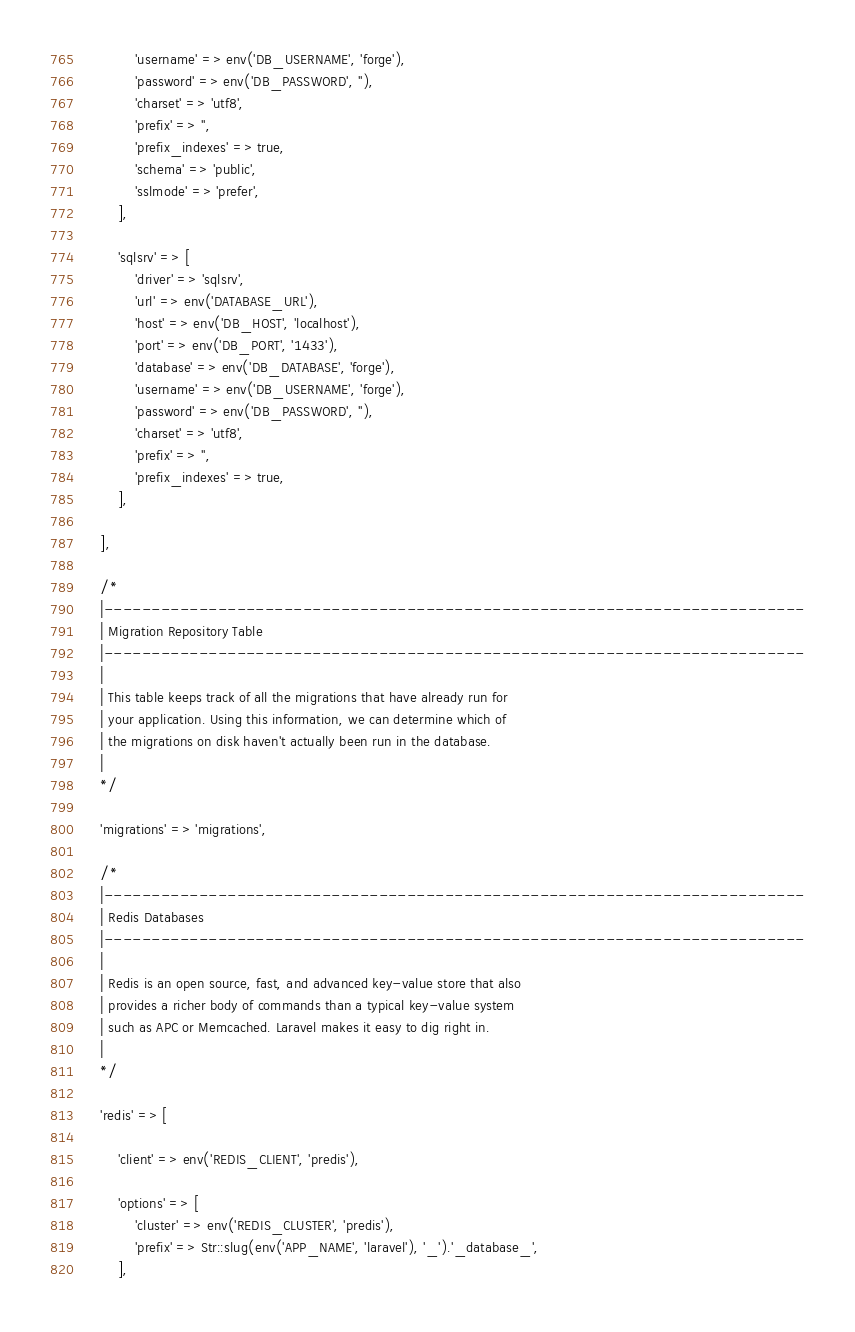<code> <loc_0><loc_0><loc_500><loc_500><_PHP_>            'username' => env('DB_USERNAME', 'forge'),
            'password' => env('DB_PASSWORD', ''),
            'charset' => 'utf8',
            'prefix' => '',
            'prefix_indexes' => true,
            'schema' => 'public',
            'sslmode' => 'prefer',
        ],

        'sqlsrv' => [
            'driver' => 'sqlsrv',
            'url' => env('DATABASE_URL'),
            'host' => env('DB_HOST', 'localhost'),
            'port' => env('DB_PORT', '1433'),
            'database' => env('DB_DATABASE', 'forge'),
            'username' => env('DB_USERNAME', 'forge'),
            'password' => env('DB_PASSWORD', ''),
            'charset' => 'utf8',
            'prefix' => '',
            'prefix_indexes' => true,
        ],

    ],

    /*
    |--------------------------------------------------------------------------
    | Migration Repository Table
    |--------------------------------------------------------------------------
    |
    | This table keeps track of all the migrations that have already run for
    | your application. Using this information, we can determine which of
    | the migrations on disk haven't actually been run in the database.
    |
    */

    'migrations' => 'migrations',

    /*
    |--------------------------------------------------------------------------
    | Redis Databases
    |--------------------------------------------------------------------------
    |
    | Redis is an open source, fast, and advanced key-value store that also
    | provides a richer body of commands than a typical key-value system
    | such as APC or Memcached. Laravel makes it easy to dig right in.
    |
    */

    'redis' => [

        'client' => env('REDIS_CLIENT', 'predis'),

        'options' => [
            'cluster' => env('REDIS_CLUSTER', 'predis'),
            'prefix' => Str::slug(env('APP_NAME', 'laravel'), '_').'_database_',
        ],
</code> 